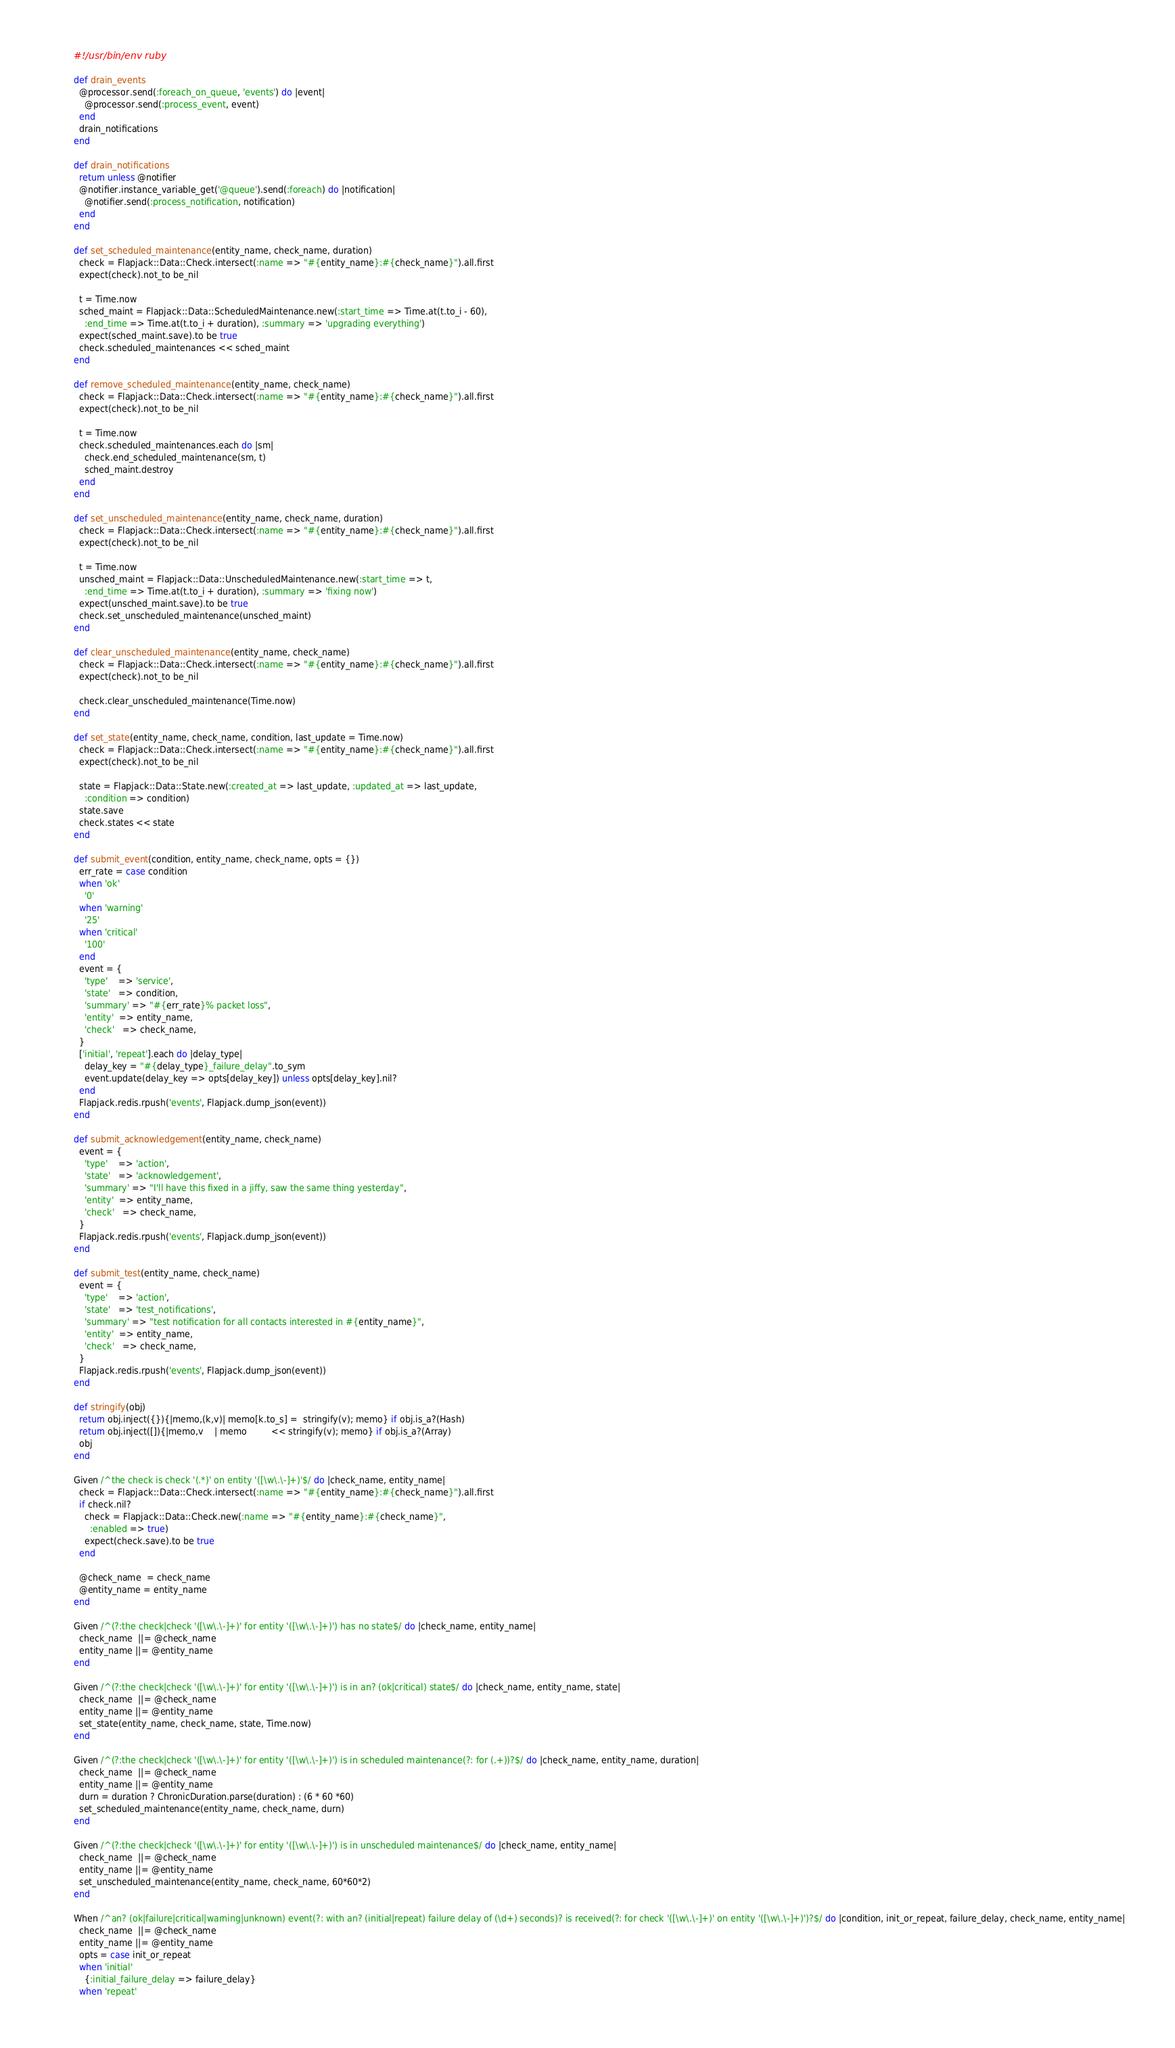Convert code to text. <code><loc_0><loc_0><loc_500><loc_500><_Ruby_>#!/usr/bin/env ruby

def drain_events
  @processor.send(:foreach_on_queue, 'events') do |event|
    @processor.send(:process_event, event)
  end
  drain_notifications
end

def drain_notifications
  return unless @notifier
  @notifier.instance_variable_get('@queue').send(:foreach) do |notification|
    @notifier.send(:process_notification, notification)
  end
end

def set_scheduled_maintenance(entity_name, check_name, duration)
  check = Flapjack::Data::Check.intersect(:name => "#{entity_name}:#{check_name}").all.first
  expect(check).not_to be_nil

  t = Time.now
  sched_maint = Flapjack::Data::ScheduledMaintenance.new(:start_time => Time.at(t.to_i - 60),
    :end_time => Time.at(t.to_i + duration), :summary => 'upgrading everything')
  expect(sched_maint.save).to be true
  check.scheduled_maintenances << sched_maint
end

def remove_scheduled_maintenance(entity_name, check_name)
  check = Flapjack::Data::Check.intersect(:name => "#{entity_name}:#{check_name}").all.first
  expect(check).not_to be_nil

  t = Time.now
  check.scheduled_maintenances.each do |sm|
    check.end_scheduled_maintenance(sm, t)
    sched_maint.destroy
  end
end

def set_unscheduled_maintenance(entity_name, check_name, duration)
  check = Flapjack::Data::Check.intersect(:name => "#{entity_name}:#{check_name}").all.first
  expect(check).not_to be_nil

  t = Time.now
  unsched_maint = Flapjack::Data::UnscheduledMaintenance.new(:start_time => t,
    :end_time => Time.at(t.to_i + duration), :summary => 'fixing now')
  expect(unsched_maint.save).to be true
  check.set_unscheduled_maintenance(unsched_maint)
end

def clear_unscheduled_maintenance(entity_name, check_name)
  check = Flapjack::Data::Check.intersect(:name => "#{entity_name}:#{check_name}").all.first
  expect(check).not_to be_nil

  check.clear_unscheduled_maintenance(Time.now)
end

def set_state(entity_name, check_name, condition, last_update = Time.now)
  check = Flapjack::Data::Check.intersect(:name => "#{entity_name}:#{check_name}").all.first
  expect(check).not_to be_nil

  state = Flapjack::Data::State.new(:created_at => last_update, :updated_at => last_update,
    :condition => condition)
  state.save
  check.states << state
end

def submit_event(condition, entity_name, check_name, opts = {})
  err_rate = case condition
  when 'ok'
    '0'
  when 'warning'
    '25'
  when 'critical'
    '100'
  end
  event = {
    'type'    => 'service',
    'state'   => condition,
    'summary' => "#{err_rate}% packet loss",
    'entity'  => entity_name,
    'check'   => check_name,
  }
  ['initial', 'repeat'].each do |delay_type|
    delay_key = "#{delay_type}_failure_delay".to_sym
    event.update(delay_key => opts[delay_key]) unless opts[delay_key].nil?
  end
  Flapjack.redis.rpush('events', Flapjack.dump_json(event))
end

def submit_acknowledgement(entity_name, check_name)
  event = {
    'type'    => 'action',
    'state'   => 'acknowledgement',
    'summary' => "I'll have this fixed in a jiffy, saw the same thing yesterday",
    'entity'  => entity_name,
    'check'   => check_name,
  }
  Flapjack.redis.rpush('events', Flapjack.dump_json(event))
end

def submit_test(entity_name, check_name)
  event = {
    'type'    => 'action',
    'state'   => 'test_notifications',
    'summary' => "test notification for all contacts interested in #{entity_name}",
    'entity'  => entity_name,
    'check'   => check_name,
  }
  Flapjack.redis.rpush('events', Flapjack.dump_json(event))
end

def stringify(obj)
  return obj.inject({}){|memo,(k,v)| memo[k.to_s] =  stringify(v); memo} if obj.is_a?(Hash)
  return obj.inject([]){|memo,v    | memo         << stringify(v); memo} if obj.is_a?(Array)
  obj
end

Given /^the check is check '(.*)' on entity '([\w\.\-]+)'$/ do |check_name, entity_name|
  check = Flapjack::Data::Check.intersect(:name => "#{entity_name}:#{check_name}").all.first
  if check.nil?
    check = Flapjack::Data::Check.new(:name => "#{entity_name}:#{check_name}",
      :enabled => true)
    expect(check.save).to be true
  end

  @check_name  = check_name
  @entity_name = entity_name
end

Given /^(?:the check|check '([\w\.\-]+)' for entity '([\w\.\-]+)') has no state$/ do |check_name, entity_name|
  check_name  ||= @check_name
  entity_name ||= @entity_name
end

Given /^(?:the check|check '([\w\.\-]+)' for entity '([\w\.\-]+)') is in an? (ok|critical) state$/ do |check_name, entity_name, state|
  check_name  ||= @check_name
  entity_name ||= @entity_name
  set_state(entity_name, check_name, state, Time.now)
end

Given /^(?:the check|check '([\w\.\-]+)' for entity '([\w\.\-]+)') is in scheduled maintenance(?: for (.+))?$/ do |check_name, entity_name, duration|
  check_name  ||= @check_name
  entity_name ||= @entity_name
  durn = duration ? ChronicDuration.parse(duration) : (6 * 60 *60)
  set_scheduled_maintenance(entity_name, check_name, durn)
end

Given /^(?:the check|check '([\w\.\-]+)' for entity '([\w\.\-]+)') is in unscheduled maintenance$/ do |check_name, entity_name|
  check_name  ||= @check_name
  entity_name ||= @entity_name
  set_unscheduled_maintenance(entity_name, check_name, 60*60*2)
end

When /^an? (ok|failure|critical|warning|unknown) event(?: with an? (initial|repeat) failure delay of (\d+) seconds)? is received(?: for check '([\w\.\-]+)' on entity '([\w\.\-]+)')?$/ do |condition, init_or_repeat, failure_delay, check_name, entity_name|
  check_name  ||= @check_name
  entity_name ||= @entity_name
  opts = case init_or_repeat
  when 'initial'
    {:initial_failure_delay => failure_delay}
  when 'repeat'</code> 